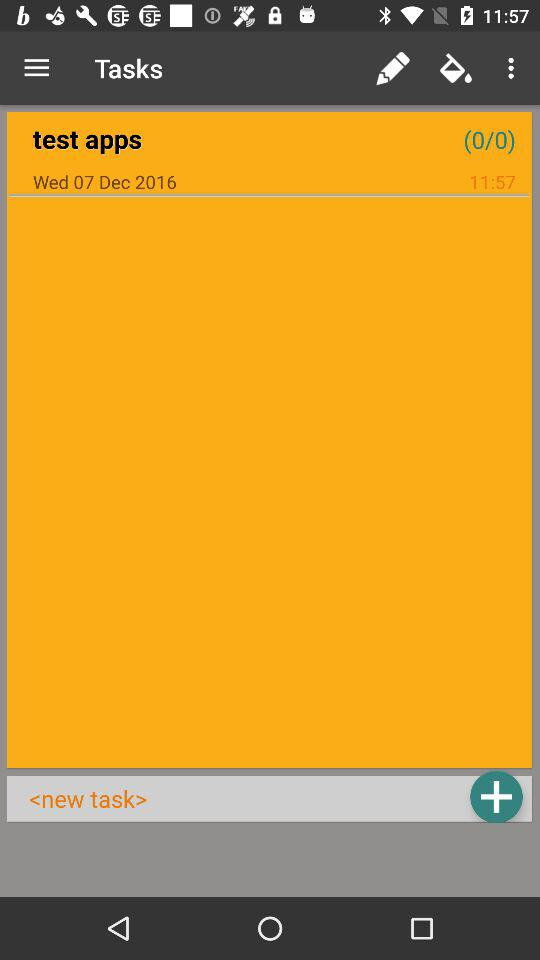What is the date? The date is Wednesday, December 7, 2016. 